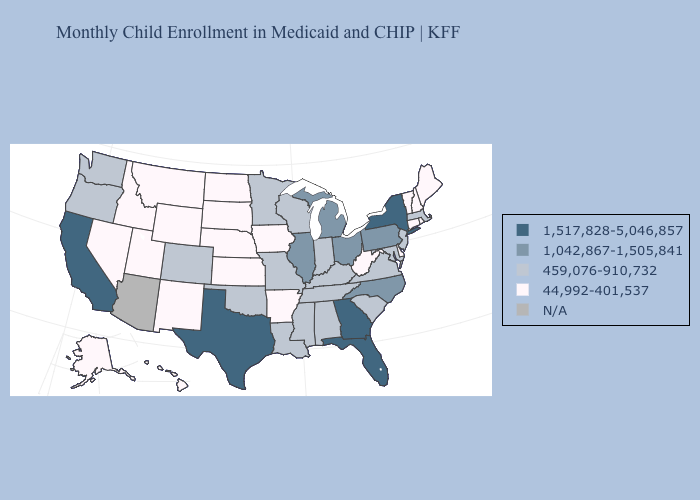Name the states that have a value in the range 44,992-401,537?
Write a very short answer. Alaska, Arkansas, Connecticut, Delaware, Hawaii, Idaho, Iowa, Kansas, Maine, Montana, Nebraska, Nevada, New Hampshire, New Mexico, North Dakota, Rhode Island, South Dakota, Utah, Vermont, West Virginia, Wyoming. What is the highest value in the USA?
Give a very brief answer. 1,517,828-5,046,857. Which states have the lowest value in the South?
Short answer required. Arkansas, Delaware, West Virginia. Does Virginia have the lowest value in the USA?
Give a very brief answer. No. Name the states that have a value in the range 1,517,828-5,046,857?
Be succinct. California, Florida, Georgia, New York, Texas. What is the value of Idaho?
Quick response, please. 44,992-401,537. What is the highest value in the USA?
Write a very short answer. 1,517,828-5,046,857. Name the states that have a value in the range 1,042,867-1,505,841?
Write a very short answer. Illinois, Michigan, North Carolina, Ohio, Pennsylvania. Among the states that border Massachusetts , does New York have the highest value?
Quick response, please. Yes. What is the lowest value in the Northeast?
Concise answer only. 44,992-401,537. Name the states that have a value in the range 44,992-401,537?
Concise answer only. Alaska, Arkansas, Connecticut, Delaware, Hawaii, Idaho, Iowa, Kansas, Maine, Montana, Nebraska, Nevada, New Hampshire, New Mexico, North Dakota, Rhode Island, South Dakota, Utah, Vermont, West Virginia, Wyoming. Does the map have missing data?
Write a very short answer. Yes. What is the value of Maryland?
Be succinct. 459,076-910,732. 